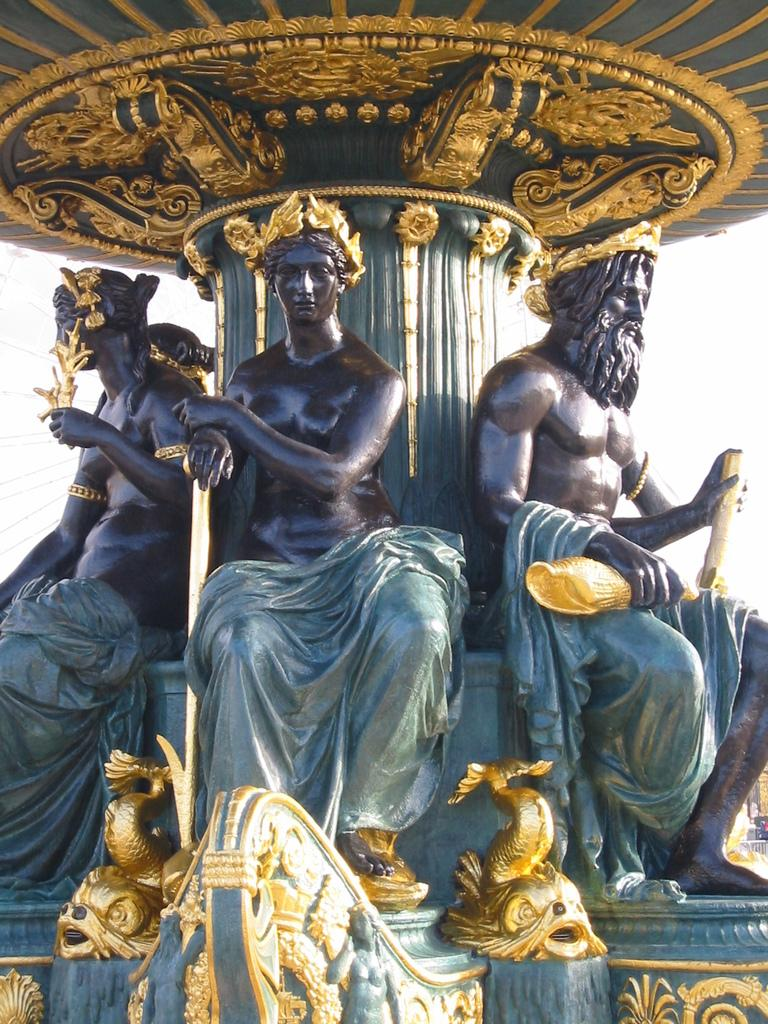What can be seen in the image? There are statues in the image. What is the color of the statues? The statues are in gray color. What is visible in the background of the image? The sky is visible in the background of the image. What is the color of the sky? The color of the sky is white. What religion do the statues represent in the image? There is no information provided about the religion represented by the statues in the image. 